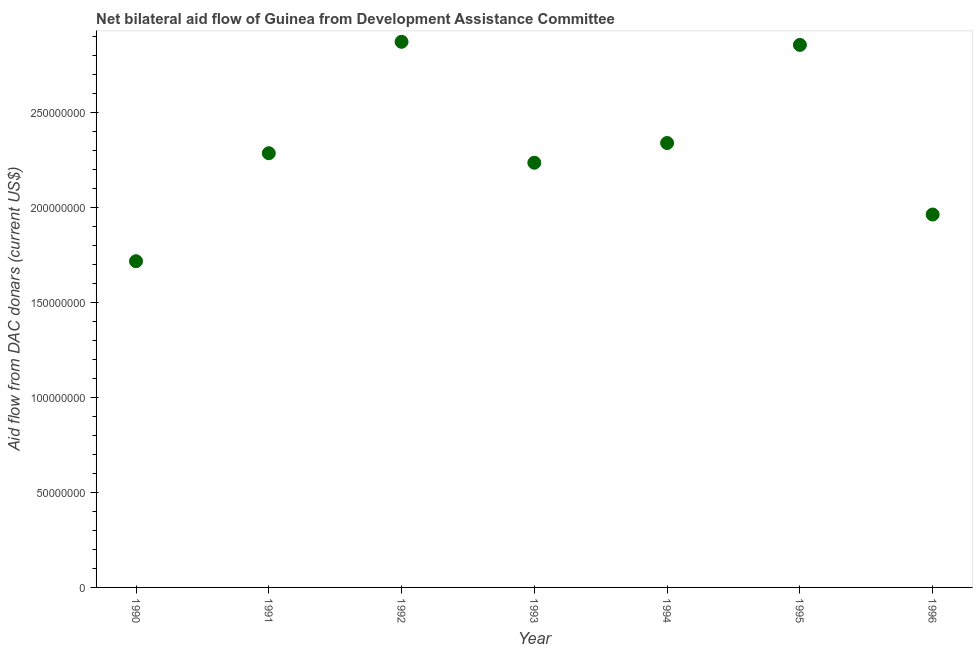What is the net bilateral aid flows from dac donors in 1993?
Your answer should be very brief. 2.23e+08. Across all years, what is the maximum net bilateral aid flows from dac donors?
Ensure brevity in your answer.  2.87e+08. Across all years, what is the minimum net bilateral aid flows from dac donors?
Ensure brevity in your answer.  1.72e+08. What is the sum of the net bilateral aid flows from dac donors?
Offer a very short reply. 1.63e+09. What is the difference between the net bilateral aid flows from dac donors in 1990 and 1992?
Ensure brevity in your answer.  -1.15e+08. What is the average net bilateral aid flows from dac donors per year?
Make the answer very short. 2.32e+08. What is the median net bilateral aid flows from dac donors?
Ensure brevity in your answer.  2.28e+08. Do a majority of the years between 1994 and 1992 (inclusive) have net bilateral aid flows from dac donors greater than 10000000 US$?
Give a very brief answer. No. What is the ratio of the net bilateral aid flows from dac donors in 1990 to that in 1994?
Your answer should be compact. 0.73. Is the difference between the net bilateral aid flows from dac donors in 1990 and 1994 greater than the difference between any two years?
Give a very brief answer. No. What is the difference between the highest and the second highest net bilateral aid flows from dac donors?
Your answer should be compact. 1.63e+06. What is the difference between the highest and the lowest net bilateral aid flows from dac donors?
Keep it short and to the point. 1.15e+08. Does the net bilateral aid flows from dac donors monotonically increase over the years?
Give a very brief answer. No. Does the graph contain any zero values?
Provide a succinct answer. No. What is the title of the graph?
Offer a terse response. Net bilateral aid flow of Guinea from Development Assistance Committee. What is the label or title of the Y-axis?
Keep it short and to the point. Aid flow from DAC donars (current US$). What is the Aid flow from DAC donars (current US$) in 1990?
Your answer should be compact. 1.72e+08. What is the Aid flow from DAC donars (current US$) in 1991?
Make the answer very short. 2.28e+08. What is the Aid flow from DAC donars (current US$) in 1992?
Offer a terse response. 2.87e+08. What is the Aid flow from DAC donars (current US$) in 1993?
Your answer should be very brief. 2.23e+08. What is the Aid flow from DAC donars (current US$) in 1994?
Provide a succinct answer. 2.34e+08. What is the Aid flow from DAC donars (current US$) in 1995?
Provide a short and direct response. 2.85e+08. What is the Aid flow from DAC donars (current US$) in 1996?
Ensure brevity in your answer.  1.96e+08. What is the difference between the Aid flow from DAC donars (current US$) in 1990 and 1991?
Offer a terse response. -5.68e+07. What is the difference between the Aid flow from DAC donars (current US$) in 1990 and 1992?
Provide a succinct answer. -1.15e+08. What is the difference between the Aid flow from DAC donars (current US$) in 1990 and 1993?
Keep it short and to the point. -5.18e+07. What is the difference between the Aid flow from DAC donars (current US$) in 1990 and 1994?
Offer a very short reply. -6.22e+07. What is the difference between the Aid flow from DAC donars (current US$) in 1990 and 1995?
Ensure brevity in your answer.  -1.14e+08. What is the difference between the Aid flow from DAC donars (current US$) in 1990 and 1996?
Your response must be concise. -2.46e+07. What is the difference between the Aid flow from DAC donars (current US$) in 1991 and 1992?
Your response must be concise. -5.86e+07. What is the difference between the Aid flow from DAC donars (current US$) in 1991 and 1993?
Offer a very short reply. 5.01e+06. What is the difference between the Aid flow from DAC donars (current US$) in 1991 and 1994?
Provide a short and direct response. -5.37e+06. What is the difference between the Aid flow from DAC donars (current US$) in 1991 and 1995?
Your response must be concise. -5.70e+07. What is the difference between the Aid flow from DAC donars (current US$) in 1991 and 1996?
Offer a very short reply. 3.23e+07. What is the difference between the Aid flow from DAC donars (current US$) in 1992 and 1993?
Keep it short and to the point. 6.36e+07. What is the difference between the Aid flow from DAC donars (current US$) in 1992 and 1994?
Your answer should be compact. 5.33e+07. What is the difference between the Aid flow from DAC donars (current US$) in 1992 and 1995?
Your response must be concise. 1.63e+06. What is the difference between the Aid flow from DAC donars (current US$) in 1992 and 1996?
Your answer should be compact. 9.09e+07. What is the difference between the Aid flow from DAC donars (current US$) in 1993 and 1994?
Make the answer very short. -1.04e+07. What is the difference between the Aid flow from DAC donars (current US$) in 1993 and 1995?
Offer a very short reply. -6.20e+07. What is the difference between the Aid flow from DAC donars (current US$) in 1993 and 1996?
Provide a succinct answer. 2.72e+07. What is the difference between the Aid flow from DAC donars (current US$) in 1994 and 1995?
Your answer should be compact. -5.16e+07. What is the difference between the Aid flow from DAC donars (current US$) in 1994 and 1996?
Give a very brief answer. 3.76e+07. What is the difference between the Aid flow from DAC donars (current US$) in 1995 and 1996?
Your response must be concise. 8.93e+07. What is the ratio of the Aid flow from DAC donars (current US$) in 1990 to that in 1991?
Keep it short and to the point. 0.75. What is the ratio of the Aid flow from DAC donars (current US$) in 1990 to that in 1992?
Give a very brief answer. 0.6. What is the ratio of the Aid flow from DAC donars (current US$) in 1990 to that in 1993?
Offer a very short reply. 0.77. What is the ratio of the Aid flow from DAC donars (current US$) in 1990 to that in 1994?
Provide a short and direct response. 0.73. What is the ratio of the Aid flow from DAC donars (current US$) in 1990 to that in 1995?
Provide a succinct answer. 0.6. What is the ratio of the Aid flow from DAC donars (current US$) in 1990 to that in 1996?
Provide a succinct answer. 0.88. What is the ratio of the Aid flow from DAC donars (current US$) in 1991 to that in 1992?
Your answer should be very brief. 0.8. What is the ratio of the Aid flow from DAC donars (current US$) in 1991 to that in 1996?
Give a very brief answer. 1.16. What is the ratio of the Aid flow from DAC donars (current US$) in 1992 to that in 1993?
Offer a terse response. 1.28. What is the ratio of the Aid flow from DAC donars (current US$) in 1992 to that in 1994?
Keep it short and to the point. 1.23. What is the ratio of the Aid flow from DAC donars (current US$) in 1992 to that in 1996?
Your answer should be very brief. 1.46. What is the ratio of the Aid flow from DAC donars (current US$) in 1993 to that in 1994?
Your response must be concise. 0.96. What is the ratio of the Aid flow from DAC donars (current US$) in 1993 to that in 1995?
Your response must be concise. 0.78. What is the ratio of the Aid flow from DAC donars (current US$) in 1993 to that in 1996?
Your answer should be very brief. 1.14. What is the ratio of the Aid flow from DAC donars (current US$) in 1994 to that in 1995?
Your response must be concise. 0.82. What is the ratio of the Aid flow from DAC donars (current US$) in 1994 to that in 1996?
Offer a very short reply. 1.19. What is the ratio of the Aid flow from DAC donars (current US$) in 1995 to that in 1996?
Offer a terse response. 1.46. 